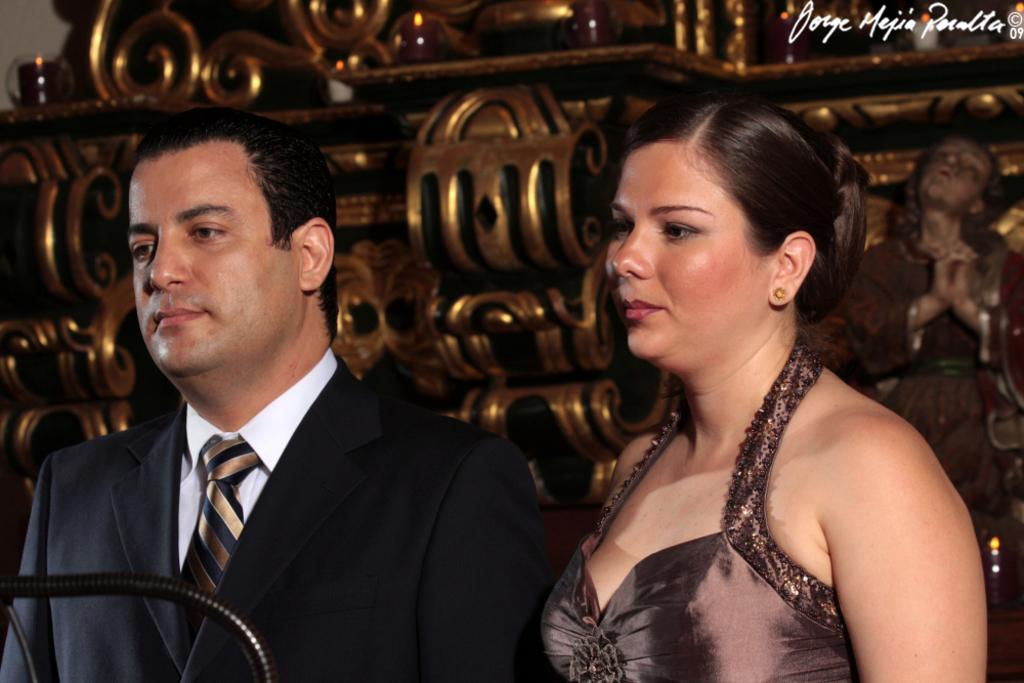How many people are present in the image? There are 2 people standing in the image. What is the person on the left wearing? The person on the left is wearing a suit. What type of government support is being discussed by the people in the image? There is no indication in the image that the people are discussing government support or any other topic. 